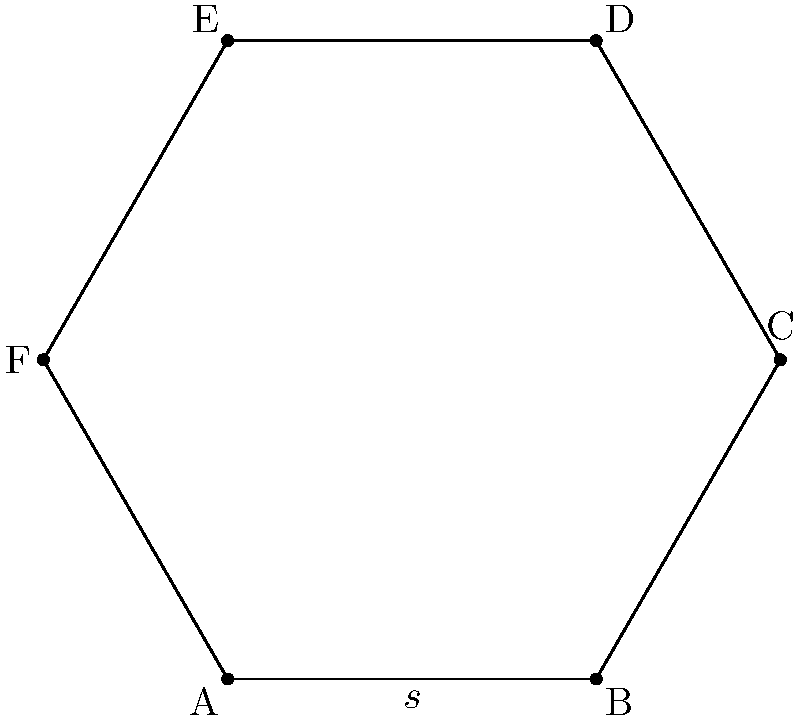In a traditional Jewish honeycomb pattern, a regular hexagon is used as the basic shape. If the side length of this hexagon is $s$ units and represents a musical note duration in your composition, what is the perimeter of the hexagon in terms of $s$? To find the perimeter of a regular hexagon, we can follow these steps:

1. Recall that a regular hexagon has 6 equal sides.

2. The perimeter is the sum of all side lengths.

3. If each side has a length of $s$ units, we can calculate the perimeter as follows:
   
   Perimeter = $6 \times s$

4. This gives us a simple formula for the perimeter of a regular hexagon in terms of its side length.

The result, $6s$, represents the total length around the hexagon, which could be interpreted musically as the total duration of a repeating pattern in your soundtrack composition.
Answer: $6s$ 